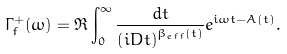<formula> <loc_0><loc_0><loc_500><loc_500>\Gamma _ { f } ^ { + } ( \omega ) = \Re \int _ { 0 } ^ { \infty } \frac { d t } { \left ( i D t \right ) ^ { \beta _ { e f f } ( t ) } } e ^ { i \omega t - A ( t ) } .</formula> 